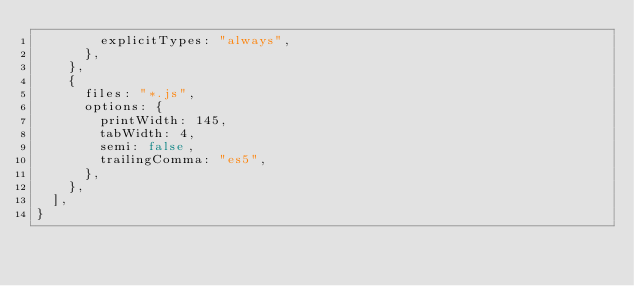Convert code to text. <code><loc_0><loc_0><loc_500><loc_500><_JavaScript_>        explicitTypes: "always",
      },
    },
    {
      files: "*.js",
      options: {
        printWidth: 145,
        tabWidth: 4,
        semi: false,
        trailingComma: "es5",
      },
    },
  ],
}
</code> 